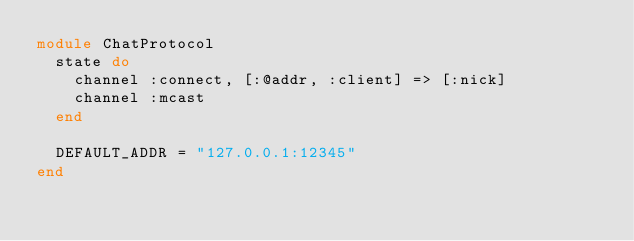<code> <loc_0><loc_0><loc_500><loc_500><_Ruby_>module ChatProtocol
  state do
    channel :connect, [:@addr, :client] => [:nick]
    channel :mcast
  end

  DEFAULT_ADDR = "127.0.0.1:12345"
end
</code> 